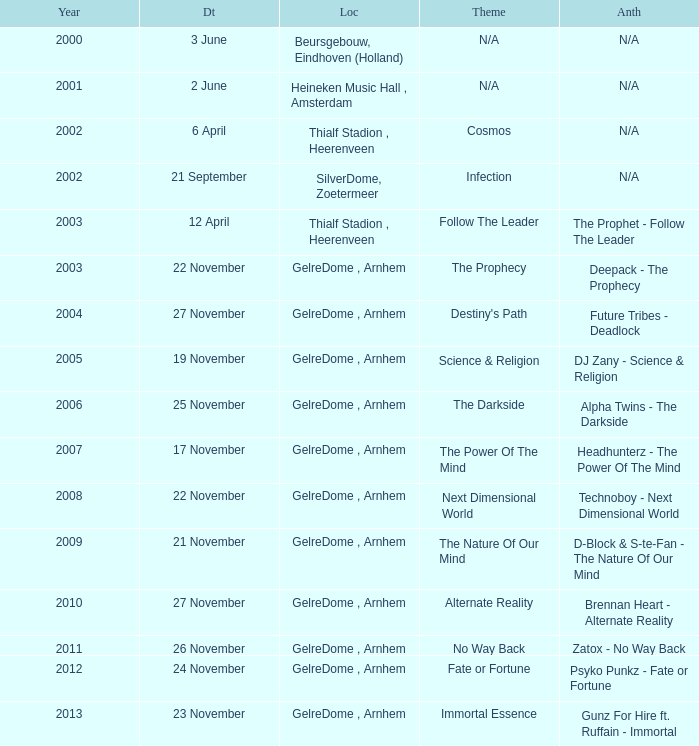What date has a theme of fate or fortune? 24 November. 